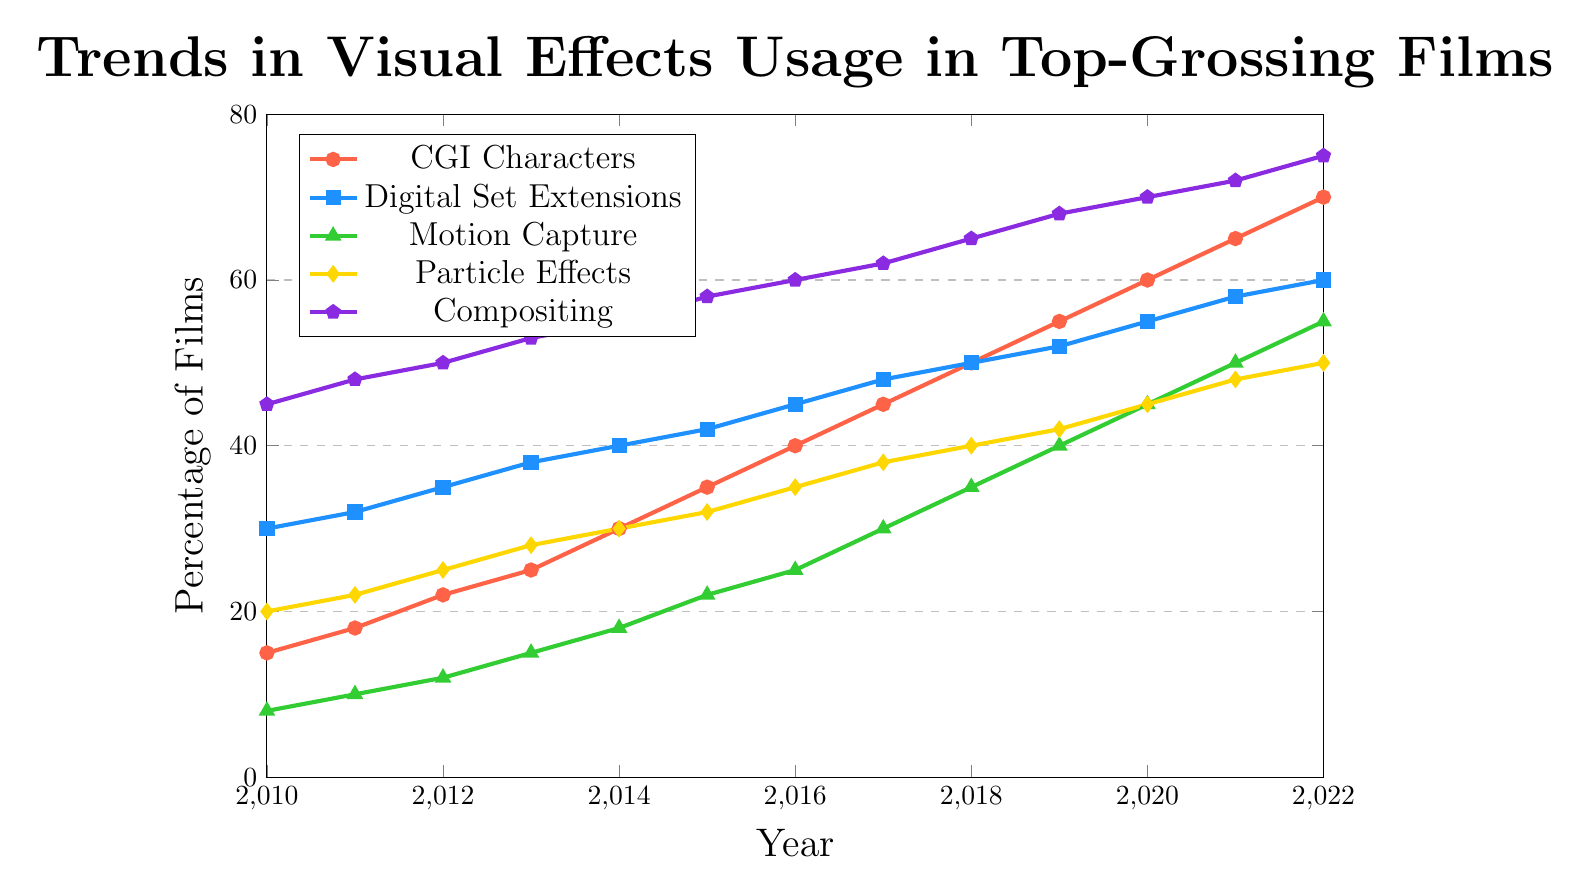What's the trend for CGI Characters from 2010 to 2022? To determine the trend for CGI Characters from 2010 to 2022, follow the red line with circles. From the chart, you can observe that the percentage of films using CGI Characters consistently increases each year, starting at 15% in 2010 and rising to 70% by 2022. This indicates a clear upward trend.
Answer: The percentage of films using CGI Characters consistently increases from 15% in 2010 to 70% in 2022 Which type of visual effect saw the highest usage in 2022? Look at the endpoints of all the lines in the chart for the year 2022. The purple line with pentagons representing Compositing ends at the highest point at 75%, compared to all other visual effects types.
Answer: Compositing In what year did Particle Effects reach 35% usage? Locate the yellow line with diamond markers representing Particle Effects and find where it crosses the 35% mark on the y-axis. This occurs in 2016.
Answer: 2016 How much did the usage of Motion Capture increase from 2010 to 2022? Identify the initial value for Motion Capture in 2010 (8%) and the final value in 2022 (55%). Find the difference: 55% - 8% = 47%.
Answer: 47% Which visual effect showed a consistent year-over-year increase in its usage? Assess the lines' progression across years. All lines (CGI Characters, Digital Set Extensions, Motion Capture, Particle Effects, and Compositing) show a consistent year-over-year increase without any decrease.
Answer: All of them What is the difference in the usage percentages of Compositing and Motion Capture in 2022? Locate the value for Compositing in 2022 (75%) and for Motion Capture in 2022 (55%). The difference is 75% - 55% = 20%.
Answer: 20% 